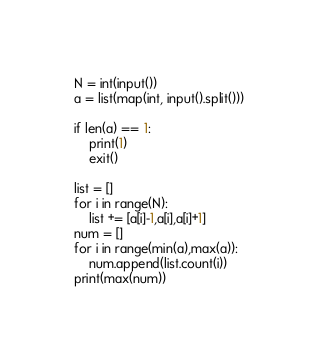<code> <loc_0><loc_0><loc_500><loc_500><_Python_>N = int(input())
a = list(map(int, input().split()))

if len(a) == 1:
    print(1)
    exit()

list = []
for i in range(N):
    list += [a[i]-1,a[i],a[i]+1]
num = []
for i in range(min(a),max(a)):
    num.append(list.count(i))
print(max(num))
</code> 